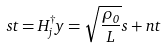Convert formula to latex. <formula><loc_0><loc_0><loc_500><loc_500>s t = H ^ { \dagger } _ { j } y = \sqrt { \frac { \rho _ { 0 } } { L } } s + n t</formula> 